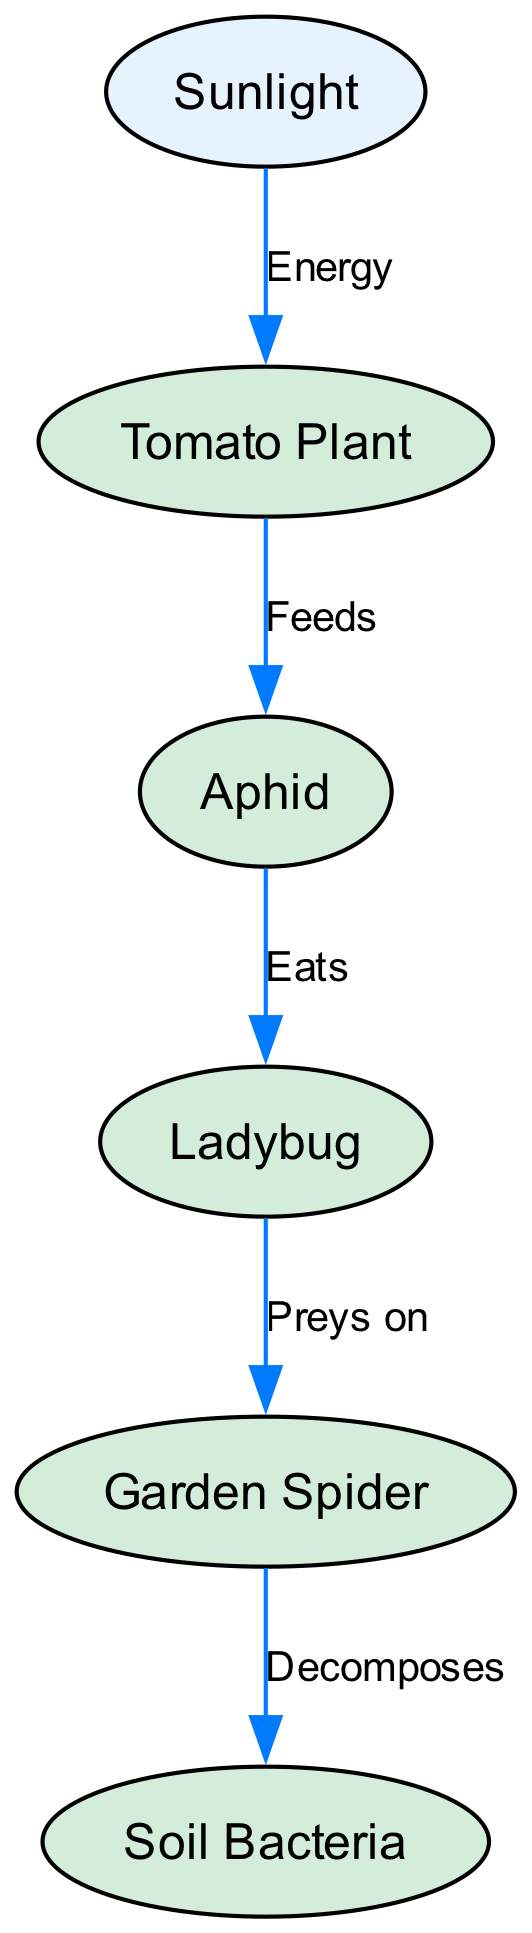What is the first node in the food chain? The first node, which represents the initial energy source in the food chain, is "Sunlight." This can be identified as there are no edges leading into it, indicating that it is the primary energy producer.
Answer: Sunlight How many nodes are present in the diagram? By counting each unique element labeled in the diagram, we find that there are a total of six nodes: Sunlight, Tomato Plant, Aphid, Ladybug, Garden Spider, and Soil Bacteria.
Answer: 6 Which organism is the direct prey of the Ladybug? The diagram indicates that the Ladybug preys on the Aphid, as shown by the connection labeled "Eats" pointing from Ladybug to Aphid.
Answer: Aphid What do Soil Bacteria do in this food chain? The Soil Bacteria are connected to the Garden Spider by an edge labeled "Decomposes." This indicates that the role of Soil Bacteria involves decomposition in the ecosystem, specifically as a result of the Garden Spider.
Answer: Decomposes Which node does the Tomato Plant receive energy from? The Tomato Plant receives energy from Sunlight, as indicated by the edge labeled "Energy" that points from Sunlight to Tomato Plant in the diagram.
Answer: Sunlight What is the flow direction of energy from the Tomato Plant? The energy flows from the Tomato Plant to the Aphid, as noted in the relationship labeled "Feeds," indicating a one-way energy transfer in the food chain.
Answer: To Aphid How many significant relationships (edges) are there in the food chain? Counting each connection depicted in the diagram, including all labels for feeding and predation, we find a total of five significant relationships or edges between the nodes.
Answer: 5 In the food chain, which two organisms are linked as predator and prey? The Garden Spider is the predator that preys on the Ladybug, which is the prey, as evidenced by the connection labeled "Preys on." This establishes the direct relationship of predation in the food chain.
Answer: Garden Spider and Ladybug What role does the Tomato Plant serve in the food chain? The Tomato Plant serves as a primary producer, receiving energy from Sunlight and providing food for the next trophic level, which is the Aphid. This role is essential as it contributes to the growth of herbivores in the chain.
Answer: Primary producer 